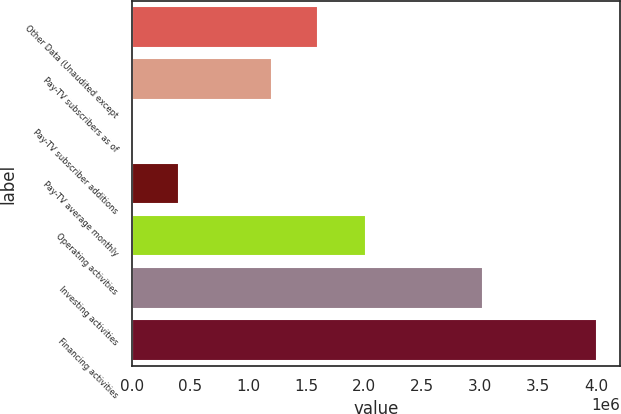<chart> <loc_0><loc_0><loc_500><loc_500><bar_chart><fcel>Other Data (Unaudited except<fcel>Pay-TV subscribers as of<fcel>Pay-TV subscriber additions<fcel>Pay-TV average monthly<fcel>Operating activities<fcel>Investing activities<fcel>Financing activities<nl><fcel>1.60099e+06<fcel>1.20075e+06<fcel>0.09<fcel>400248<fcel>2.01188e+06<fcel>3.01921e+06<fcel>4.00248e+06<nl></chart> 